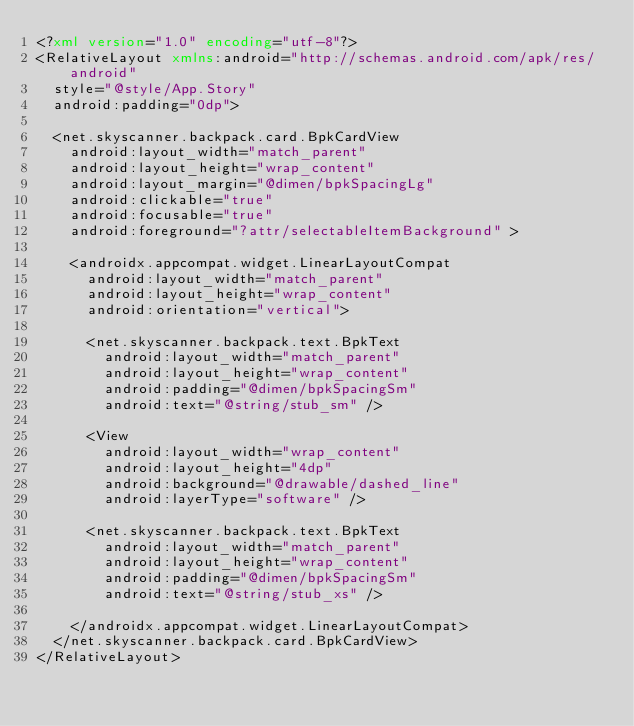<code> <loc_0><loc_0><loc_500><loc_500><_XML_><?xml version="1.0" encoding="utf-8"?>
<RelativeLayout xmlns:android="http://schemas.android.com/apk/res/android"
  style="@style/App.Story"
  android:padding="0dp">

  <net.skyscanner.backpack.card.BpkCardView
    android:layout_width="match_parent"
    android:layout_height="wrap_content"
    android:layout_margin="@dimen/bpkSpacingLg"
    android:clickable="true"
    android:focusable="true"
    android:foreground="?attr/selectableItemBackground" >

    <androidx.appcompat.widget.LinearLayoutCompat
      android:layout_width="match_parent"
      android:layout_height="wrap_content"
      android:orientation="vertical">

      <net.skyscanner.backpack.text.BpkText
        android:layout_width="match_parent"
        android:layout_height="wrap_content"
        android:padding="@dimen/bpkSpacingSm"
        android:text="@string/stub_sm" />

      <View
        android:layout_width="wrap_content"
        android:layout_height="4dp"
        android:background="@drawable/dashed_line"
        android:layerType="software" />

      <net.skyscanner.backpack.text.BpkText
        android:layout_width="match_parent"
        android:layout_height="wrap_content"
        android:padding="@dimen/bpkSpacingSm"
        android:text="@string/stub_xs" />

    </androidx.appcompat.widget.LinearLayoutCompat>
  </net.skyscanner.backpack.card.BpkCardView>
</RelativeLayout>
</code> 